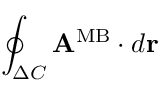Convert formula to latex. <formula><loc_0><loc_0><loc_500><loc_500>\oint _ { \Delta C } { A } ^ { M B } \cdot d { r }</formula> 